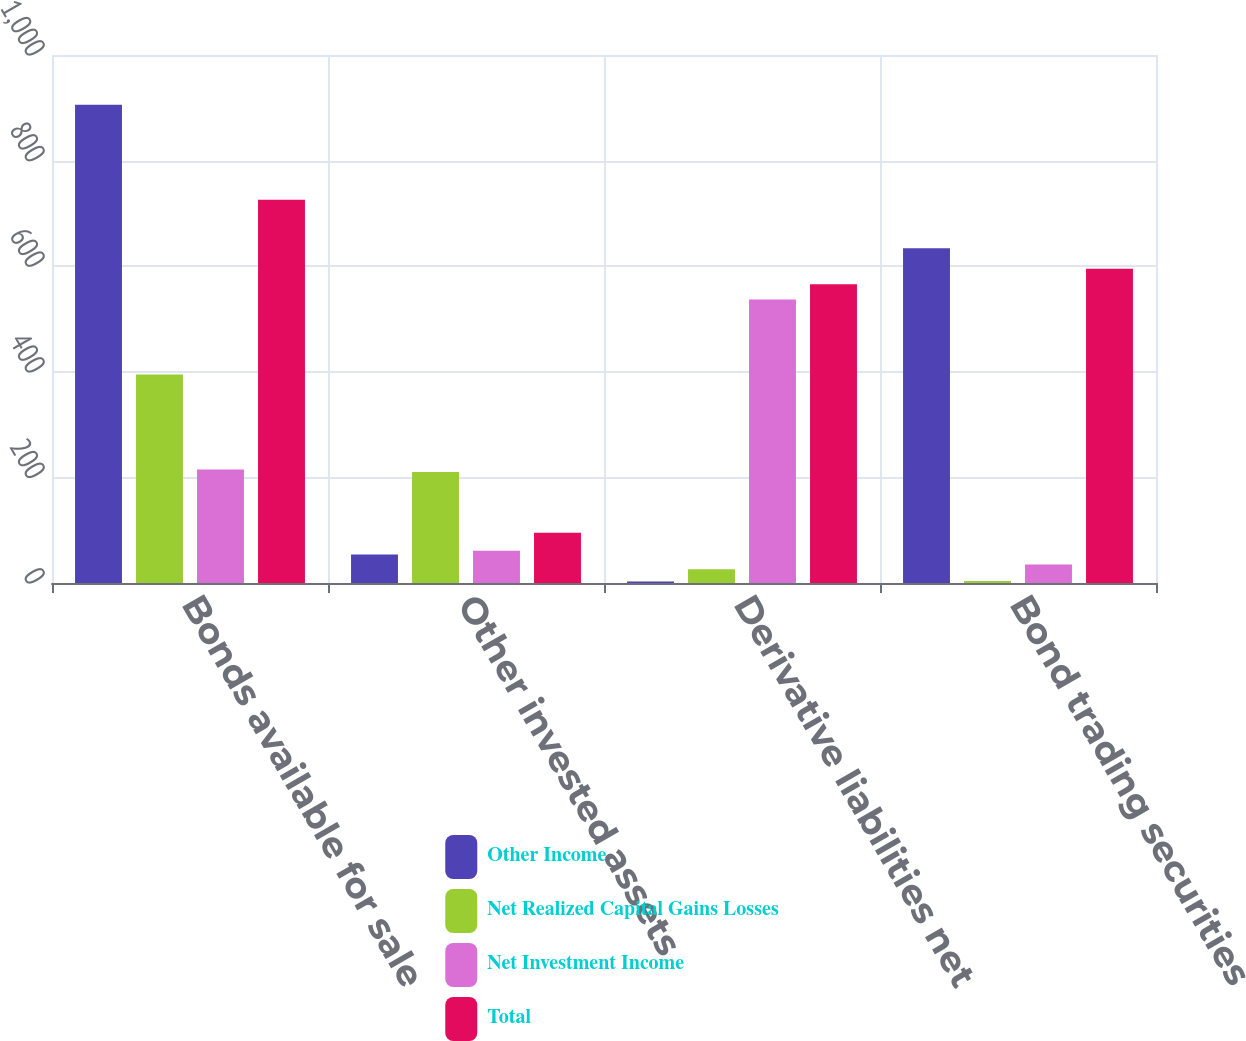Convert chart to OTSL. <chart><loc_0><loc_0><loc_500><loc_500><stacked_bar_chart><ecel><fcel>Bonds available for sale<fcel>Other invested assets<fcel>Derivative liabilities net<fcel>Bond trading securities<nl><fcel>Other Income<fcel>906<fcel>54<fcel>3<fcel>634<nl><fcel>Net Realized Capital Gains Losses<fcel>395<fcel>210<fcel>26<fcel>4<nl><fcel>Net Investment Income<fcel>215<fcel>61<fcel>537<fcel>35<nl><fcel>Total<fcel>726<fcel>95<fcel>566<fcel>595<nl></chart> 